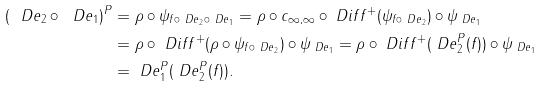<formula> <loc_0><loc_0><loc_500><loc_500>( \ D e _ { 2 } \circ \ D e _ { 1 } ) ^ { P } & = \rho \circ \psi _ { f \circ \ D e _ { 2 } \circ \ D e _ { 1 } } = \rho \circ c _ { \infty , \infty } \circ \ D i f f ^ { + } ( \psi _ { f \circ \ D e _ { 2 } } ) \circ \psi _ { \ D e _ { 1 } } \\ & = \rho \circ \ D i f f ^ { + } ( \rho \circ \psi _ { f \circ \ D e _ { 2 } } ) \circ \psi _ { \ D e _ { 1 } } = \rho \circ \ D i f f ^ { + } ( \ D e _ { 2 } ^ { P } ( f ) ) \circ \psi _ { \ D e _ { 1 } } \\ & = \ D e _ { 1 } ^ { P } ( \ D e _ { 2 } ^ { P } ( f ) ) .</formula> 